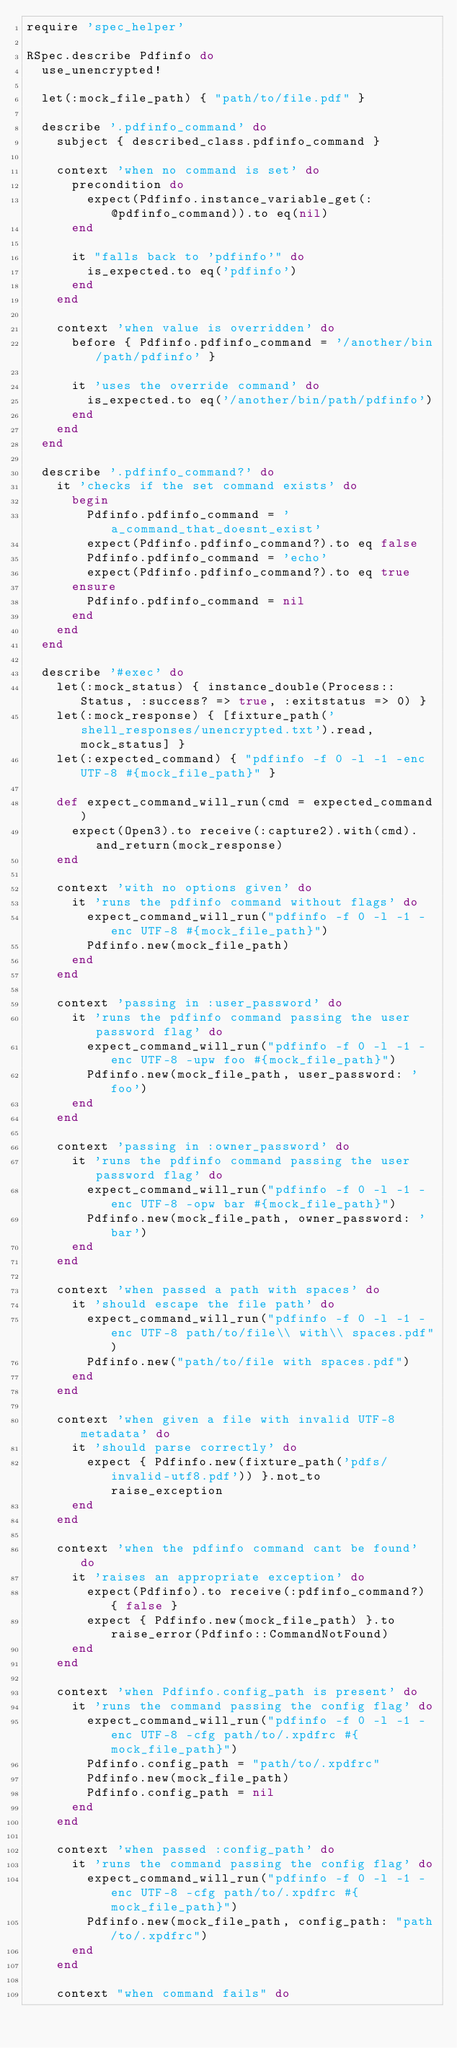Convert code to text. <code><loc_0><loc_0><loc_500><loc_500><_Ruby_>require 'spec_helper'

RSpec.describe Pdfinfo do
  use_unencrypted!

  let(:mock_file_path) { "path/to/file.pdf" }

  describe '.pdfinfo_command' do
    subject { described_class.pdfinfo_command }

    context 'when no command is set' do
      precondition do
        expect(Pdfinfo.instance_variable_get(:@pdfinfo_command)).to eq(nil)
      end

      it "falls back to 'pdfinfo'" do
        is_expected.to eq('pdfinfo')
      end
    end

    context 'when value is overridden' do
      before { Pdfinfo.pdfinfo_command = '/another/bin/path/pdfinfo' }

      it 'uses the override command' do
        is_expected.to eq('/another/bin/path/pdfinfo')
      end
    end
  end

  describe '.pdfinfo_command?' do
    it 'checks if the set command exists' do
      begin
        Pdfinfo.pdfinfo_command = 'a_command_that_doesnt_exist'
        expect(Pdfinfo.pdfinfo_command?).to eq false
        Pdfinfo.pdfinfo_command = 'echo'
        expect(Pdfinfo.pdfinfo_command?).to eq true
      ensure
        Pdfinfo.pdfinfo_command = nil
      end
    end
  end

  describe '#exec' do
    let(:mock_status) { instance_double(Process::Status, :success? => true, :exitstatus => 0) }
    let(:mock_response) { [fixture_path('shell_responses/unencrypted.txt').read, mock_status] }
    let(:expected_command) { "pdfinfo -f 0 -l -1 -enc UTF-8 #{mock_file_path}" }

    def expect_command_will_run(cmd = expected_command)
      expect(Open3).to receive(:capture2).with(cmd).and_return(mock_response)
    end

    context 'with no options given' do
      it 'runs the pdfinfo command without flags' do
        expect_command_will_run("pdfinfo -f 0 -l -1 -enc UTF-8 #{mock_file_path}")
        Pdfinfo.new(mock_file_path)
      end
    end

    context 'passing in :user_password' do
      it 'runs the pdfinfo command passing the user password flag' do
        expect_command_will_run("pdfinfo -f 0 -l -1 -enc UTF-8 -upw foo #{mock_file_path}")
        Pdfinfo.new(mock_file_path, user_password: 'foo')
      end
    end

    context 'passing in :owner_password' do
      it 'runs the pdfinfo command passing the user password flag' do
        expect_command_will_run("pdfinfo -f 0 -l -1 -enc UTF-8 -opw bar #{mock_file_path}")
        Pdfinfo.new(mock_file_path, owner_password: 'bar')
      end
    end

    context 'when passed a path with spaces' do
      it 'should escape the file path' do
        expect_command_will_run("pdfinfo -f 0 -l -1 -enc UTF-8 path/to/file\\ with\\ spaces.pdf")
        Pdfinfo.new("path/to/file with spaces.pdf")
      end
    end

    context 'when given a file with invalid UTF-8 metadata' do
      it 'should parse correctly' do
        expect { Pdfinfo.new(fixture_path('pdfs/invalid-utf8.pdf')) }.not_to raise_exception
      end
    end

    context 'when the pdfinfo command cant be found' do
      it 'raises an appropriate exception' do
        expect(Pdfinfo).to receive(:pdfinfo_command?) { false }
        expect { Pdfinfo.new(mock_file_path) }.to raise_error(Pdfinfo::CommandNotFound)
      end
    end

    context 'when Pdfinfo.config_path is present' do
      it 'runs the command passing the config flag' do
        expect_command_will_run("pdfinfo -f 0 -l -1 -enc UTF-8 -cfg path/to/.xpdfrc #{mock_file_path}")
        Pdfinfo.config_path = "path/to/.xpdfrc"
        Pdfinfo.new(mock_file_path)
        Pdfinfo.config_path = nil
      end
    end

    context 'when passed :config_path' do
      it 'runs the command passing the config flag' do
        expect_command_will_run("pdfinfo -f 0 -l -1 -enc UTF-8 -cfg path/to/.xpdfrc #{mock_file_path}")
        Pdfinfo.new(mock_file_path, config_path: "path/to/.xpdfrc")
      end
    end

    context "when command fails" do</code> 